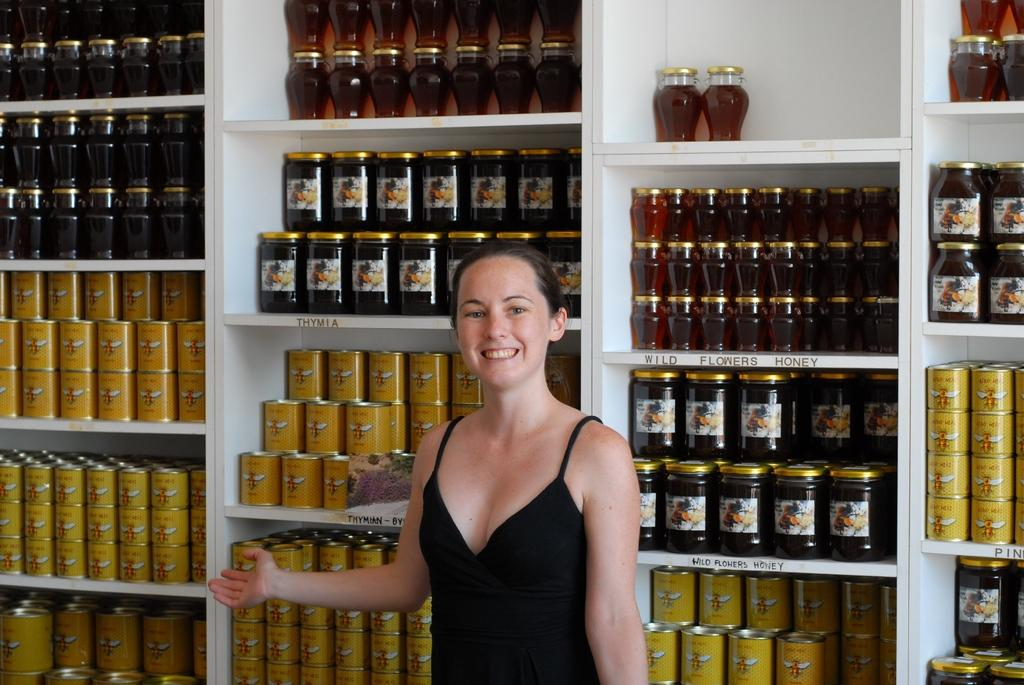Who is present in the image? There is a woman in the image. What is the woman doing in the image? The woman is standing and smiling. What can be seen in the background of the image? There are jars in racks in the background of the image. What type of kick does the woman perform in the image? There is no kick performed by the woman in the image; she is simply standing and smiling. 